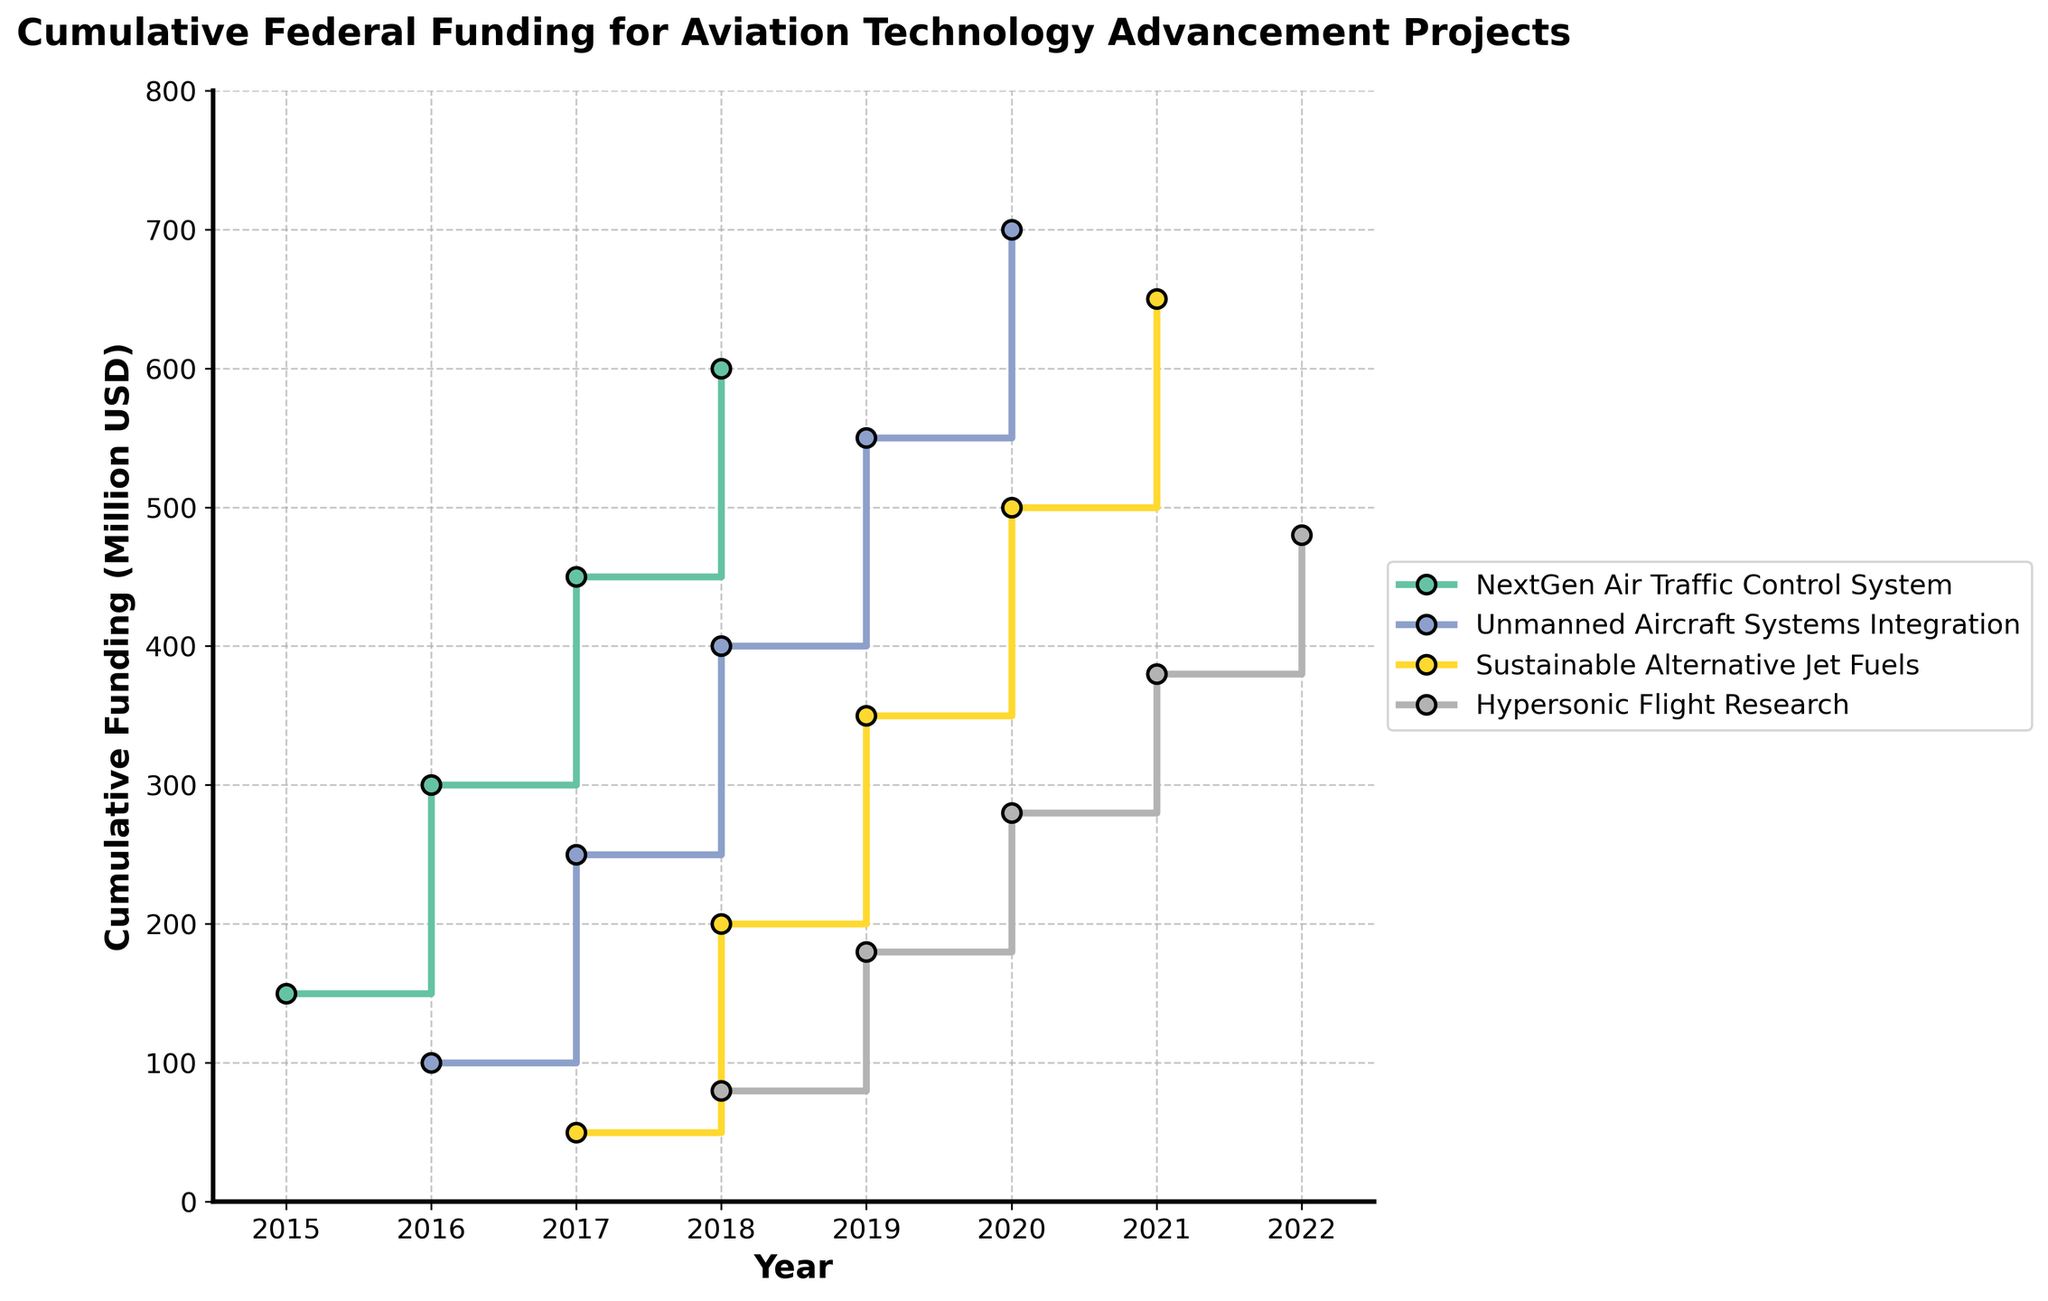What is the title of the plot? The title of the plot is located at the top and is usually the largest text on the figure. It provides an overview of what the plot depicts. The title on this plot is "Cumulative Federal Funding for Aviation Technology Advancement Projects."
Answer: Cumulative Federal Funding for Aviation Technology Advancement Projects How many aviation technology projects are depicted in the plot? By looking at the legend on the right side of the plot, which labels each represented project, we can count the number of distinct aviation technology projects. The legend shows "NextGen Air Traffic Control System," "Unmanned Aircraft Systems Integration," "Sustainable Alternative Jet Fuels," and "Hypersonic Flight Research."
Answer: 4 What was the cumulative federal funding for the NextGen Air Traffic Control System in 2018? To find this, we locate the 2018 mark on the x-axis and find the corresponding y-axis value for the step line representing the "NextGen Air Traffic Control System." According to the plot, the cumulative funding reaches 600 million USD.
Answer: 600 million USD Which project had the highest cumulative funding in 2021? By examining the 2021 mark on the x-axis and comparing the y-values of all the projects' step lines at this point, we see that "Sustainable Alternative Jet Fuels" goes up to 650 million USD, which is the highest among all.
Answer: Sustainable Alternative Jet Fuels Between which consecutive years did the Unmanned Aircraft Systems Integration project see the largest increase in funding? Observe the step jumps in the funding line for "Unmanned Aircraft Systems Integration." The largest vertical distance between steps is seen between 2019 and 2020, where the funding increases from 550 million to 700 million USD, a difference of 150 million USD.
Answer: Between 2019 and 2020 Compare the federal funding for Hypersonic Flight Research in 2019 and Sustainable Alternative Jet Fuels in 2019. Which project received more funding and by how much? In 2019, look at the y-values for both projects. "Hypersonic Flight Research" reaches 180 million USD, whereas "Sustainable Alternative Jet Fuels" reaches 350 million USD. The difference is 350 million USD - 180 million USD = 170 million USD.
Answer: Sustainable Alternative Jet Fuels by 170 million USD Calculate the total cumulative funding for "Unmanned Aircraft Systems Integration" in 2017 and "Sustainable Alternative Jet Fuels" in 2018 combined. From the plot, "Unmanned Aircraft Systems Integration" is funded at 250 million USD in 2017 and "Sustainable Alternative Jet Fuels" at 200 million USD in 2018. Summing these gives 250 million USD + 200 million USD = 450 million USD.
Answer: 450 million USD Identify the year when "Hypersonic Flight Research" first appeared on the chart and state its funding level for that year. Locate the starting point of the "Hypersonic Flight Research" step line and note the x-value. This step line starts from the year 2018. Check the y-axis to see that the initial funding level is 80 million USD.
Answer: 2018, 80 million USD How does the cumulative funding for NextGen Air Traffic Control System in 2017 compare to Unmanned Aircraft Systems Integration in 2019? From the plot, in 2017, the "NextGen Air Traffic Control System" reaches 450 million USD. In 2019, "Unmanned Aircraft Systems Integration" hits 550 million USD. Therefore, "Unmanned Aircraft Systems Integration" in 2019 has 100 million USD more funding.
Answer: Unmanned Aircraft Systems Integration in 2019 by 100 million USD What are the cumulative funding values for all projects in 2020? For the year 2020, observe the y-values for each step line. "NextGen Air Traffic Control System" has 600 million USD, "Unmanned Aircraft Systems Integration" has 700 million USD, "Sustainable Alternative Jet Fuels" has 500 million USD, and "Hypersonic Flight Research" has 280 million USD.
Answer: 600 million USD, 700 million USD, 500 million USD, 280 million USD 